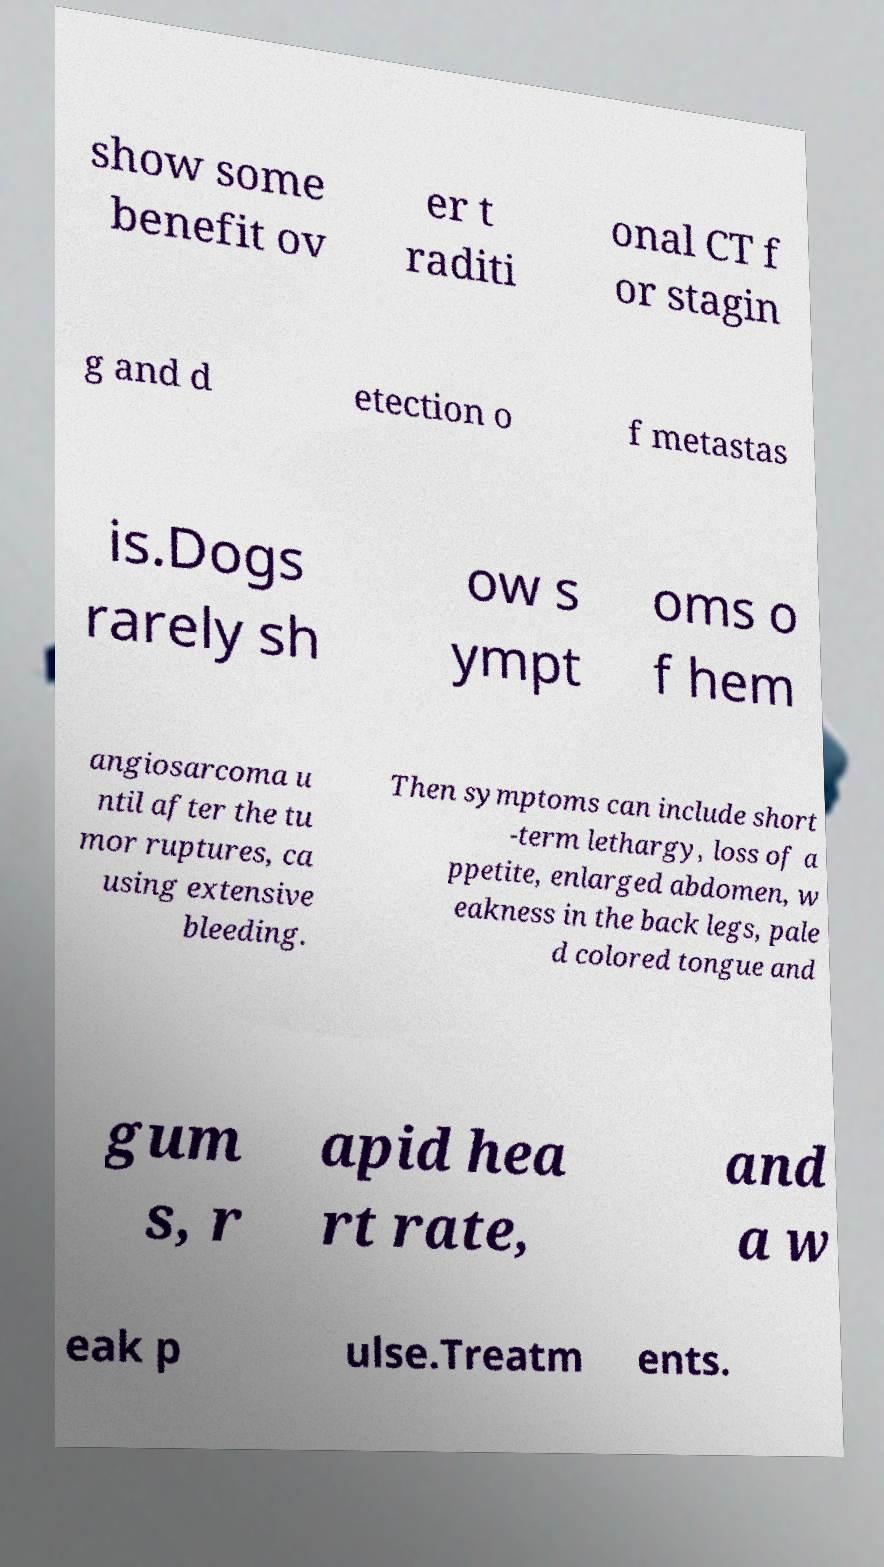Can you accurately transcribe the text from the provided image for me? show some benefit ov er t raditi onal CT f or stagin g and d etection o f metastas is.Dogs rarely sh ow s ympt oms o f hem angiosarcoma u ntil after the tu mor ruptures, ca using extensive bleeding. Then symptoms can include short -term lethargy, loss of a ppetite, enlarged abdomen, w eakness in the back legs, pale d colored tongue and gum s, r apid hea rt rate, and a w eak p ulse.Treatm ents. 